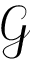<formula> <loc_0><loc_0><loc_500><loc_500>\mathcal { G }</formula> 